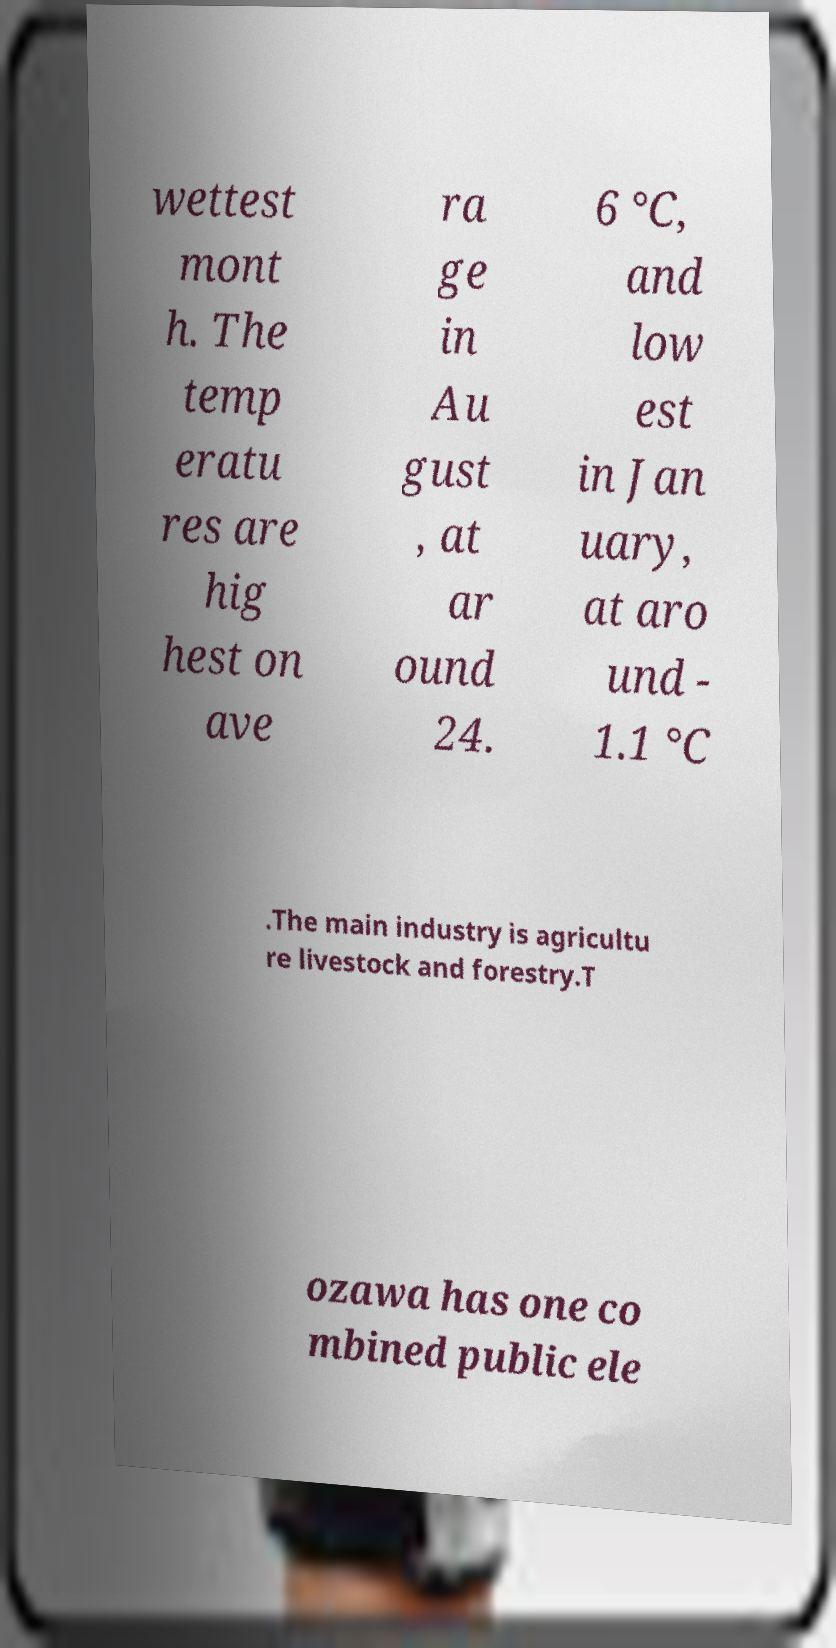Can you accurately transcribe the text from the provided image for me? wettest mont h. The temp eratu res are hig hest on ave ra ge in Au gust , at ar ound 24. 6 °C, and low est in Jan uary, at aro und - 1.1 °C .The main industry is agricultu re livestock and forestry.T ozawa has one co mbined public ele 